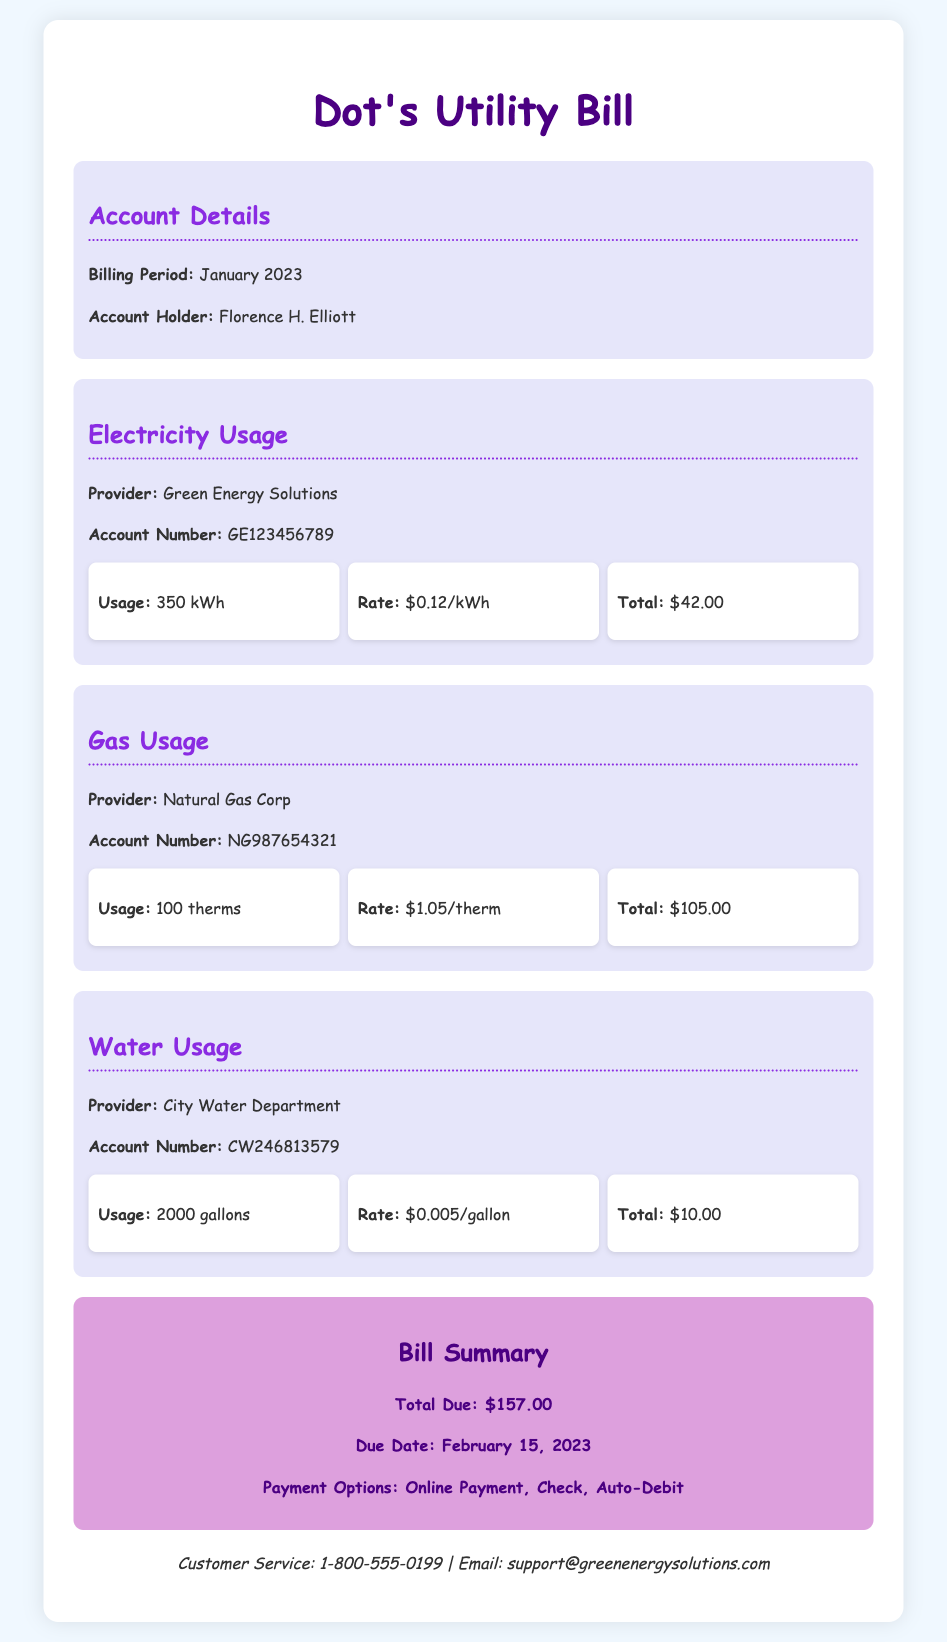What is the billing period? The billing period is clearly mentioned in the document as "January 2023."
Answer: January 2023 Who is the account holder? The account holder is listed under the "Account Details" section as "Florence H. Elliott."
Answer: Florence H. Elliott What is the total electricity charge? The total electricity charge is specified in the "Electricity Usage" section as "$42.00."
Answer: $42.00 What is the total gas charge? The document states the total gas charge in the "Gas Usage" section as "$105.00."
Answer: $105.00 What is the due date for the bill? The due date is mentioned in the "Bill Summary" section as "February 15, 2023."
Answer: February 15, 2023 Calculate the total utility charges. The total utility charges are the sum of electricity, gas, and water charges: $42.00 + $105.00 + $10.00 = $157.00.
Answer: $157.00 What payment options are available? The payment options are listed in the "Bill Summary" section as "Online Payment, Check, Auto-Debit."
Answer: Online Payment, Check, Auto-Debit What is the usage for water? The usage for water is specified in the "Water Usage" section as "2000 gallons."
Answer: 2000 gallons Who is the provider for gas? The provider for gas is clearly stated in the "Gas Usage" section as "Natural Gas Corp."
Answer: Natural Gas Corp 